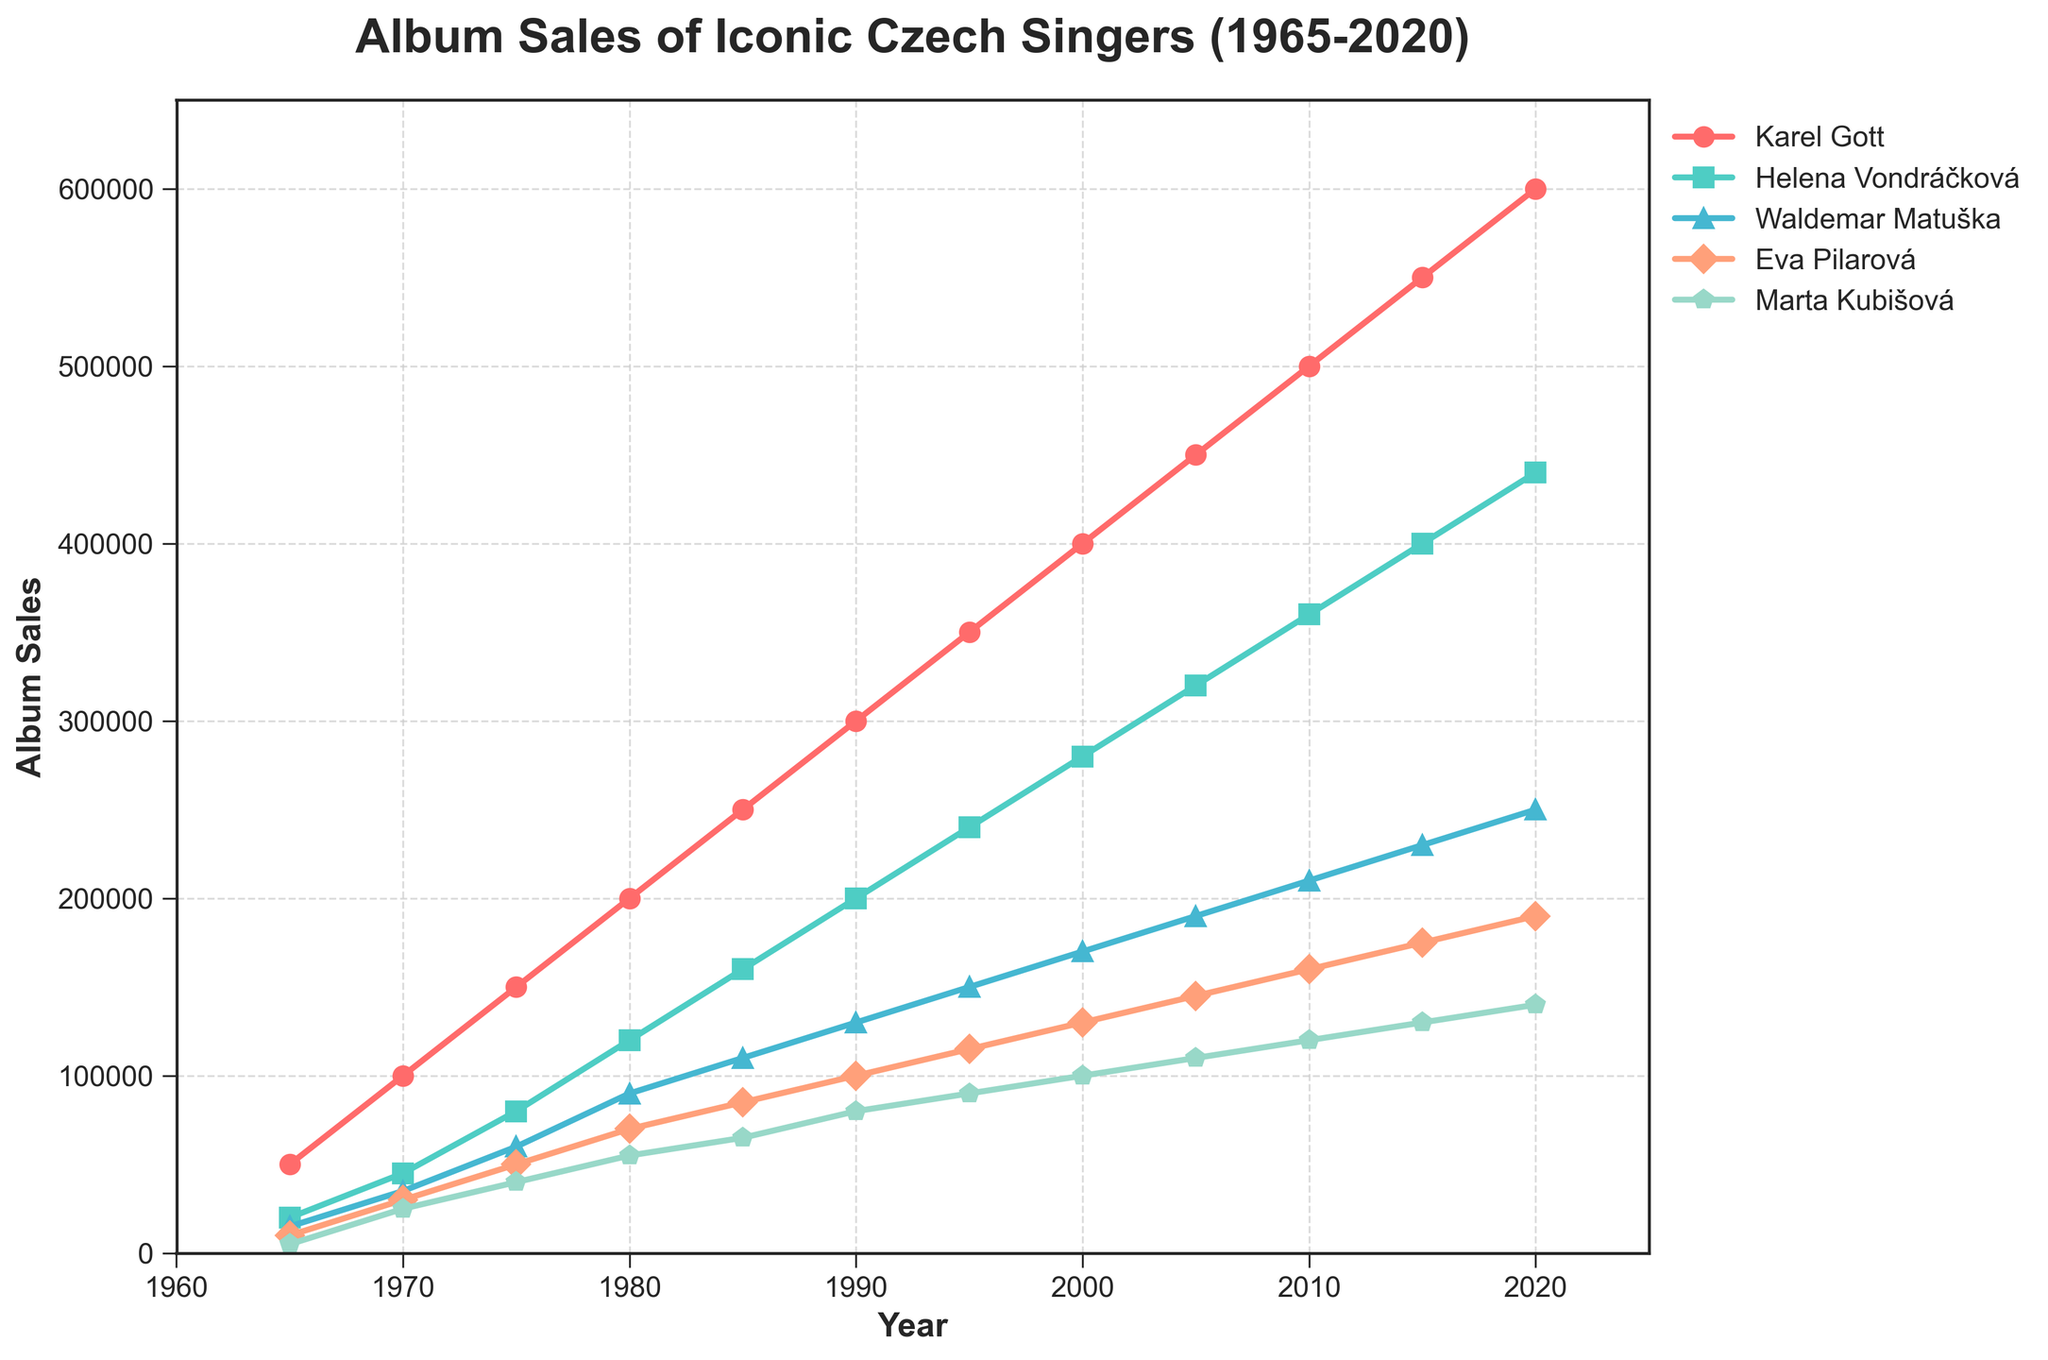Which singer had the highest album sales in 1985? Look at the 1985 data on the x-axis, then find the highest point among the lines representing different singers, which corresponds to Karel Gott.
Answer: Karel Gott Compare the album sales of Eva Pilarová in 1970 and 2000. How much did her sales increase by? Identify the points for Eva Pilarová in 1970 and 2000, which are 30,000 and 130,000 respectively. Subtract the 1970 sales from the 2000 sales to find the increase: 130,000 - 30,000.
Answer: 100,000 What was the average album sales of Helena Vondráčková over the years shown? Add up the sales for Helena Vondráčková from each year and divide by the number of years (11). The sales are: 20,000, 45,000, 80,000, 120,000, 160,000, 200,000, 240,000, 280,000, 320,000, 360,000, 400,000, 440,000. Sum = 2,665,000. Average = 2,665,000/11.
Answer: 242,273 Which singer showed the greatest increase in album sales between 1965 and 2020? Compare the album sales of each singer at the start (1965) and end (2020). Calculate the differences for each singer: Karel Gott (600,000 - 50,000), Helena Vondráčková (440,000 - 20,000), Waldemar Matuška (250,000 - 15,000), Eva Pilarová (190,000 - 10,000), Marta Kubišová (140,000 - 5,000). The largest increase is for Karel Gott.
Answer: Karel Gott By how much did Waldemar Matuška's album sales increase from 1965 to 2010? Locate Waldemar Matuška's sales in 1965 and 2010: 15,000 and 210,000. Subtract the 1965 sales from the 2010 sales: 210,000 - 15,000.
Answer: 195,000 Which two years show the largest jump in album sales for Marta Kubišová? Observe Marta Kubišová’s line and identify where the gap between two consecutive years is the largest. The jump appears largest from 1965 (5,000) to 1970 (25,000), an increase of 20,000.
Answer: 1965 to 1970 When do Eva Pilarová's sales surpass 100,000 albums? Look at Eva Pilarová’s line and identify the year when her sales first exceed 100,000. This occurs between 1980 and 1985.
Answer: 1985 How do Marta Kubišová's album sales in 1995 compare to those in 2015? Check Marta Kubišová’s sales in 1995 (90,000) and 2015 (130,000). Subtract the earlier sales from the later sales to find the increase: 130,000 - 90,000.
Answer: 40,000 Which singer has the closest album sales to 300,000 in the year 2000? Check album sales for all singers in the year 2000. Karel Gott has 400,000, Helena Vondráčková has 280,000, Waldemar Matuška has 170,000, Eva Pilarová has 130,000, Marta Kubišová has 100,000. The closest to 300,000 is Helena Vondráčková with 280,000.
Answer: Helena Vondráčková 